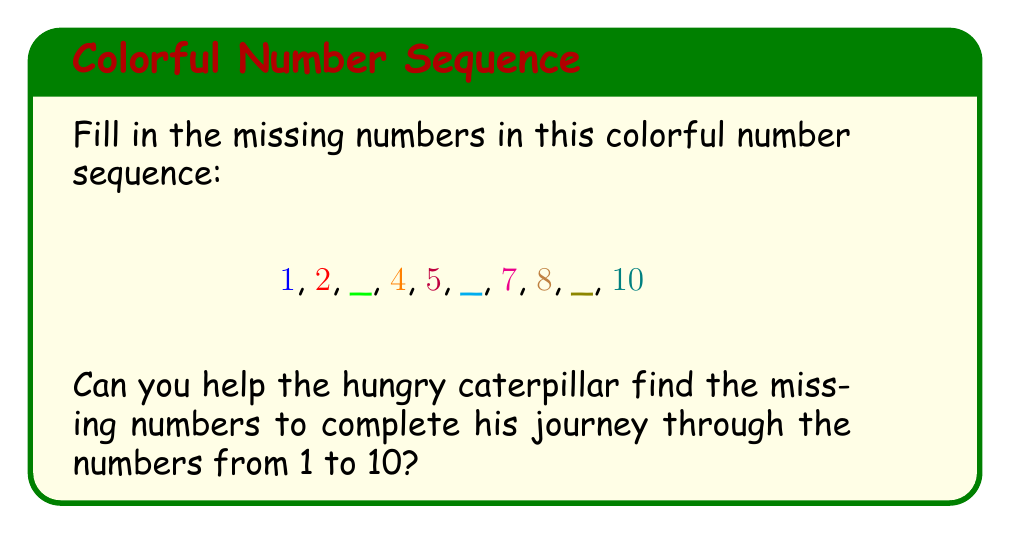Help me with this question. Let's help the hungry caterpillar fill in the missing numbers:

1. We start with the numbers we can see: $1, 2, 4, 5, 7, 8, 10$

2. We know that we're looking at a sequence from 1 to 10, so all numbers should be in order.

3. Let's look at the first gap:
   - It comes after 2 and before 4
   - The only number that fits here is 3

4. For the second gap:
   - It's between 5 and 7
   - The only number that fits here is 6

5. For the last gap:
   - It's between 8 and 10
   - The only number that fits here is 9

6. Now we have the complete sequence:
   $1, 2, 3, 4, 5, 6, 7, 8, 9, 10$

The hungry caterpillar has successfully found all the missing numbers!
Answer: $3, 6, 9$ 